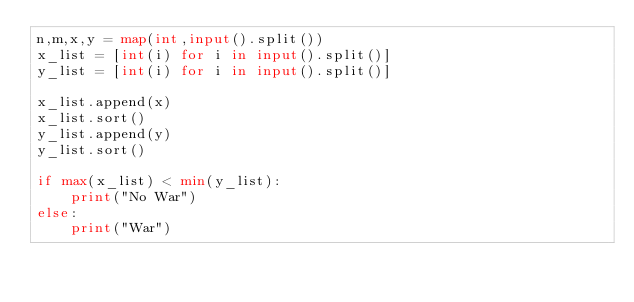<code> <loc_0><loc_0><loc_500><loc_500><_Python_>n,m,x,y = map(int,input().split())
x_list = [int(i) for i in input().split()]
y_list = [int(i) for i in input().split()]

x_list.append(x)
x_list.sort()
y_list.append(y)
y_list.sort()

if max(x_list) < min(y_list):
    print("No War")
else:
    print("War")</code> 